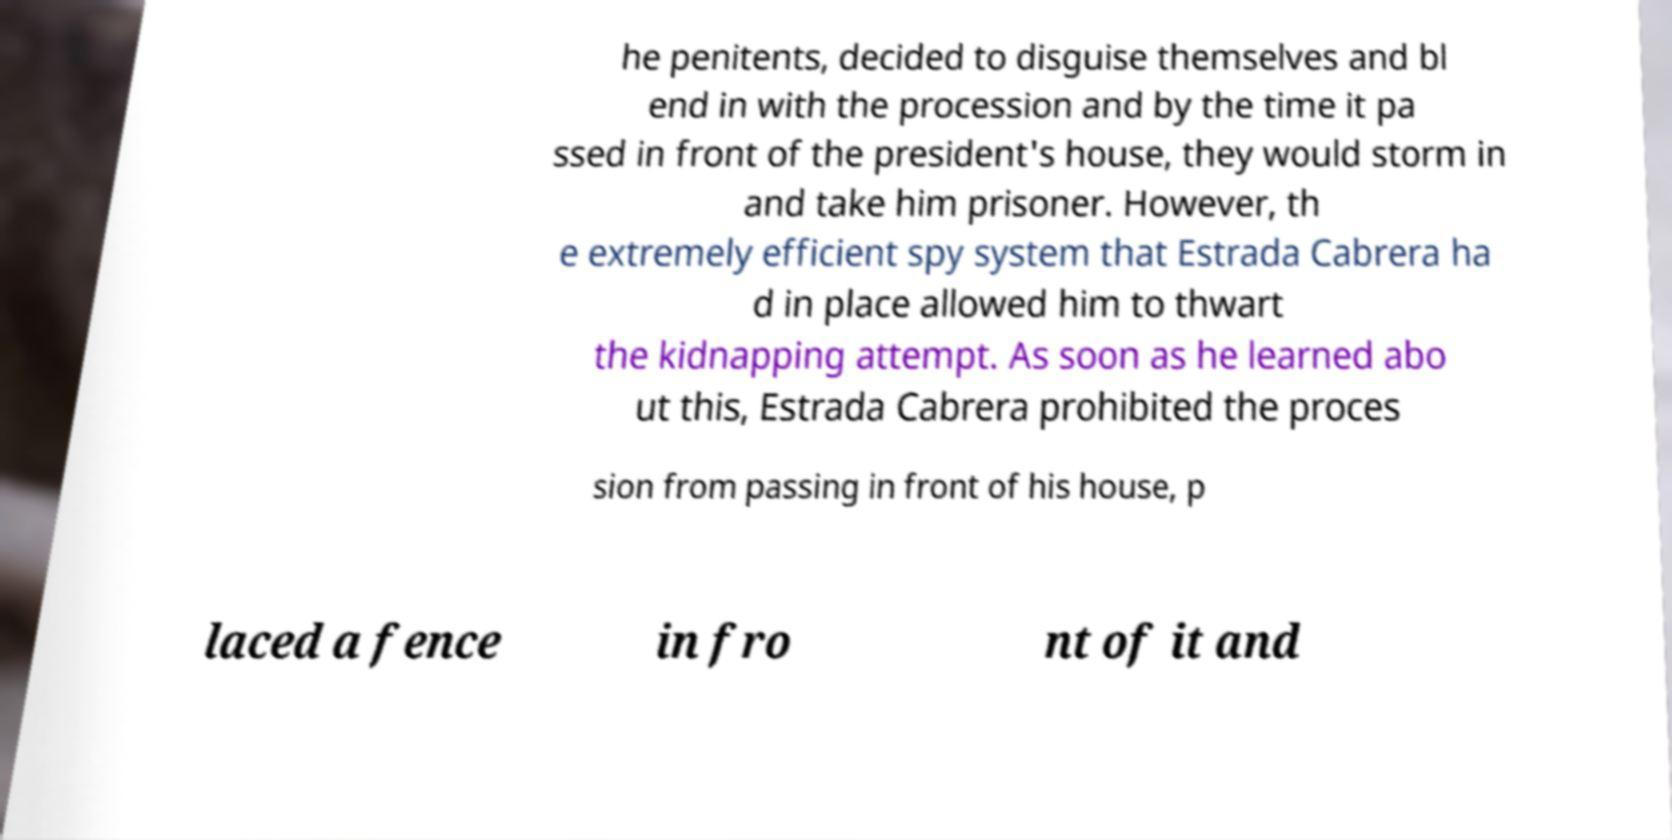Please identify and transcribe the text found in this image. he penitents, decided to disguise themselves and bl end in with the procession and by the time it pa ssed in front of the president's house, they would storm in and take him prisoner. However, th e extremely efficient spy system that Estrada Cabrera ha d in place allowed him to thwart the kidnapping attempt. As soon as he learned abo ut this, Estrada Cabrera prohibited the proces sion from passing in front of his house, p laced a fence in fro nt of it and 